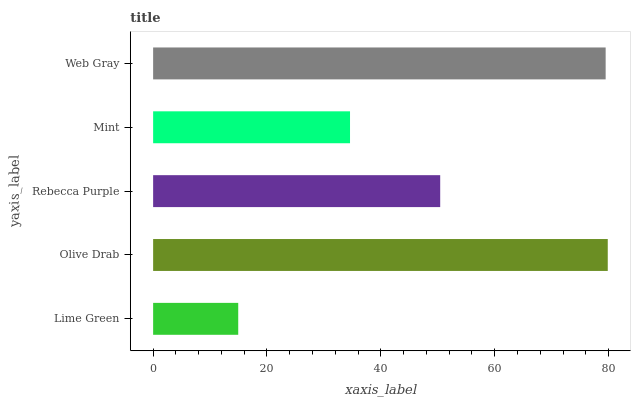Is Lime Green the minimum?
Answer yes or no. Yes. Is Olive Drab the maximum?
Answer yes or no. Yes. Is Rebecca Purple the minimum?
Answer yes or no. No. Is Rebecca Purple the maximum?
Answer yes or no. No. Is Olive Drab greater than Rebecca Purple?
Answer yes or no. Yes. Is Rebecca Purple less than Olive Drab?
Answer yes or no. Yes. Is Rebecca Purple greater than Olive Drab?
Answer yes or no. No. Is Olive Drab less than Rebecca Purple?
Answer yes or no. No. Is Rebecca Purple the high median?
Answer yes or no. Yes. Is Rebecca Purple the low median?
Answer yes or no. Yes. Is Lime Green the high median?
Answer yes or no. No. Is Olive Drab the low median?
Answer yes or no. No. 